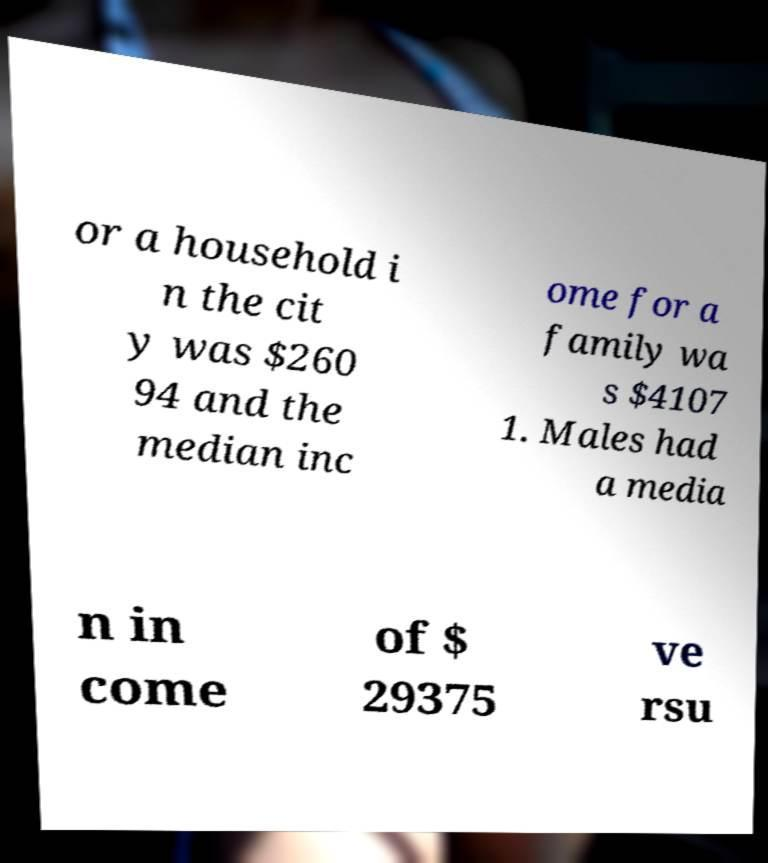Could you extract and type out the text from this image? or a household i n the cit y was $260 94 and the median inc ome for a family wa s $4107 1. Males had a media n in come of $ 29375 ve rsu 